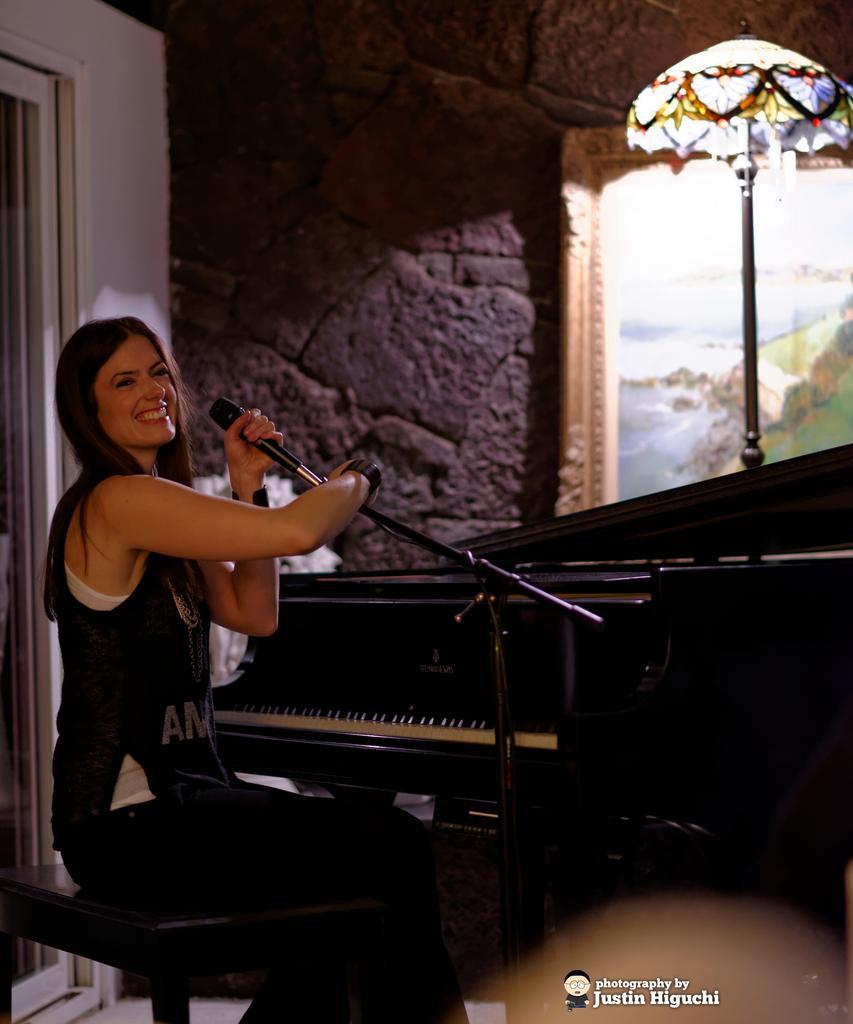Describe this image in one or two sentences. In this image I can see a person sitting in front of the piano and holding the mic. Opposite to her there is a frame attached to the wall and the frame contains water,trees and the sky. 